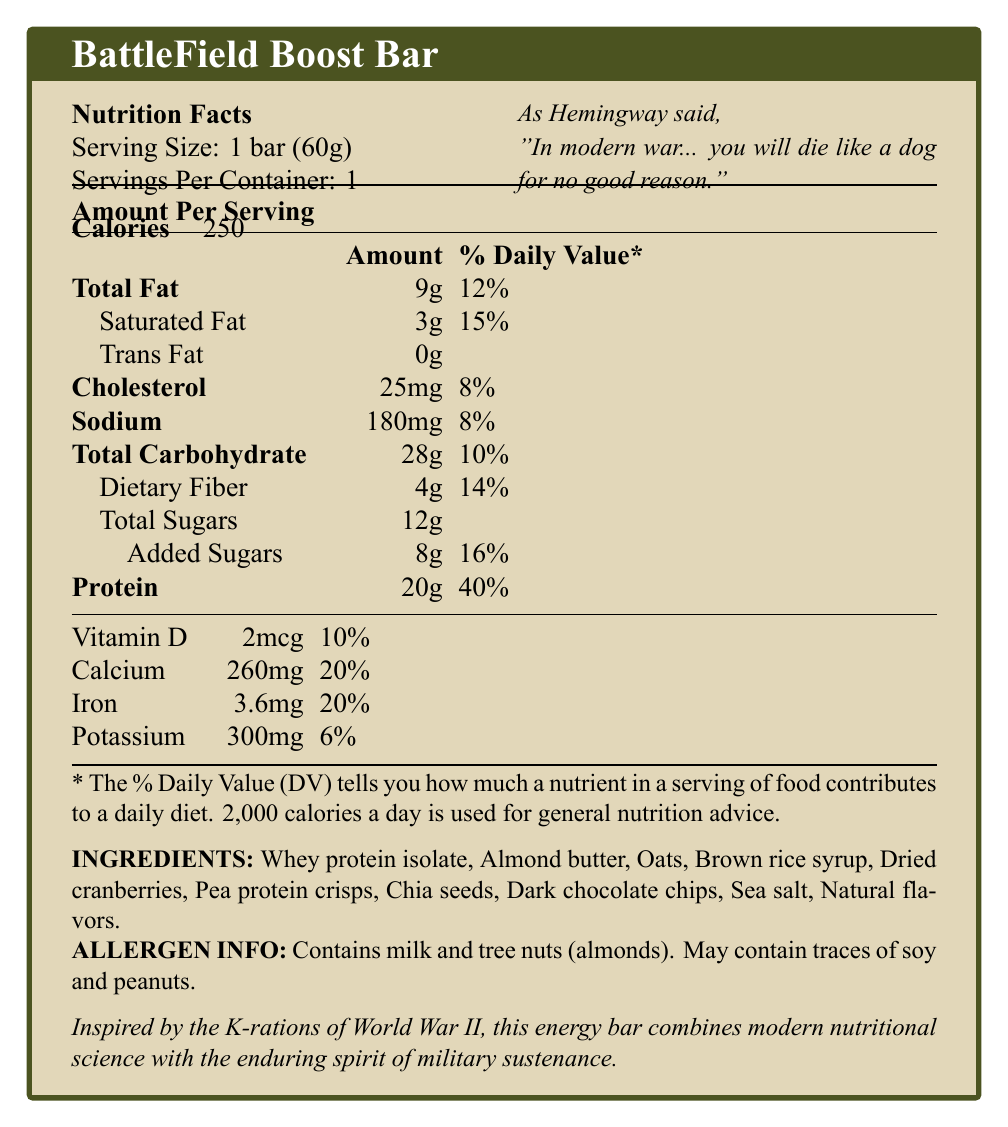what is the serving size? The serving size is specified in the initial section of the document under "Serving Size."
Answer: 1 bar (60g) how many calories are in one serving of the BattleField Boost Bar? The calories per serving are listed under "Calories" in the "Amount Per Serving" section.
Answer: 250 what is the amount of protein in the BattleField Boost Bar? The protein content is found under "Protein" in the nutritional facts table.
Answer: 20g list three key ingredients in the BattleField Boost Bar. These ingredients are listed under the "INGREDIENTS" section.
Answer: Whey protein isolate, Almond butter, Oats what percentage of the daily value of iron does the bar provide? The daily value percentage for iron is given in the vitamins and minerals section of the nutritional facts.
Answer: 20% what is the total fat content in the bar? The total fat content is listed under "Total Fat" in the nutritional facts table.
Answer: 9g what is the added sugar content in the bar? A. 4g B. 8g C. 12g D. 16g The added sugar content of 8g is listed under "Added Sugars" in the nutritional facts.
Answer: B which of the following allergens are present in the BattleField Boost Bar? I. Milk II. Tree nuts III. Peanuts IV. Soy The allergen information states that the bar contains milk and tree nuts (almonds) and may contain traces of soy and peanuts.
Answer: I. Milk, II. Tree nuts is there any trans fat in the BattleField Boost Bar? The trans fat content is listed as 0g in the nutritional facts.
Answer: No which historical context inspired the creation of the BattleField Boost Bar? The historical context is described under the "Inspired by the K-rations of World War II" section of the document.
Answer: Inspired by the K-rations of World War II what is the main idea of the document? The primary objective of the document is to lay out the nutritional content and inspiration behind the BattleField Boost Bar.
Answer: The document provides nutritional information about the BattleField Boost Bar, a high-protein energy bar inspired by military rations, specifying its ingredients, allergen information, and historical context. what percentage of the daily value of calcium does one bar provide? The daily value percentage for calcium is listed as 20% in the vitamins and minerals section.
Answer: 20% what is the sodium content in the bar? The sodium content is listed under "Sodium" in the nutritional facts table.
Answer: 180mg can this document tell me the company that manufactures the BattleField Boost Bar? The document doesn't provide any information about the manufacturer or company behind the product.
Answer: Cannot be determined 